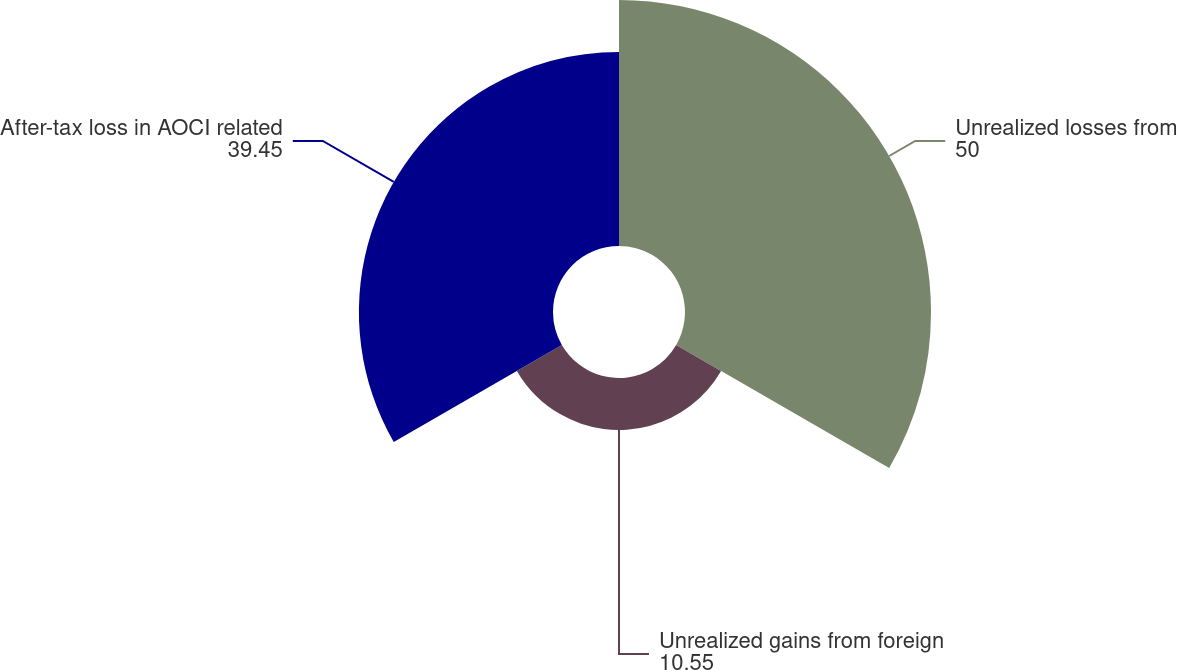Convert chart to OTSL. <chart><loc_0><loc_0><loc_500><loc_500><pie_chart><fcel>Unrealized losses from<fcel>Unrealized gains from foreign<fcel>After-tax loss in AOCI related<nl><fcel>50.0%<fcel>10.55%<fcel>39.45%<nl></chart> 